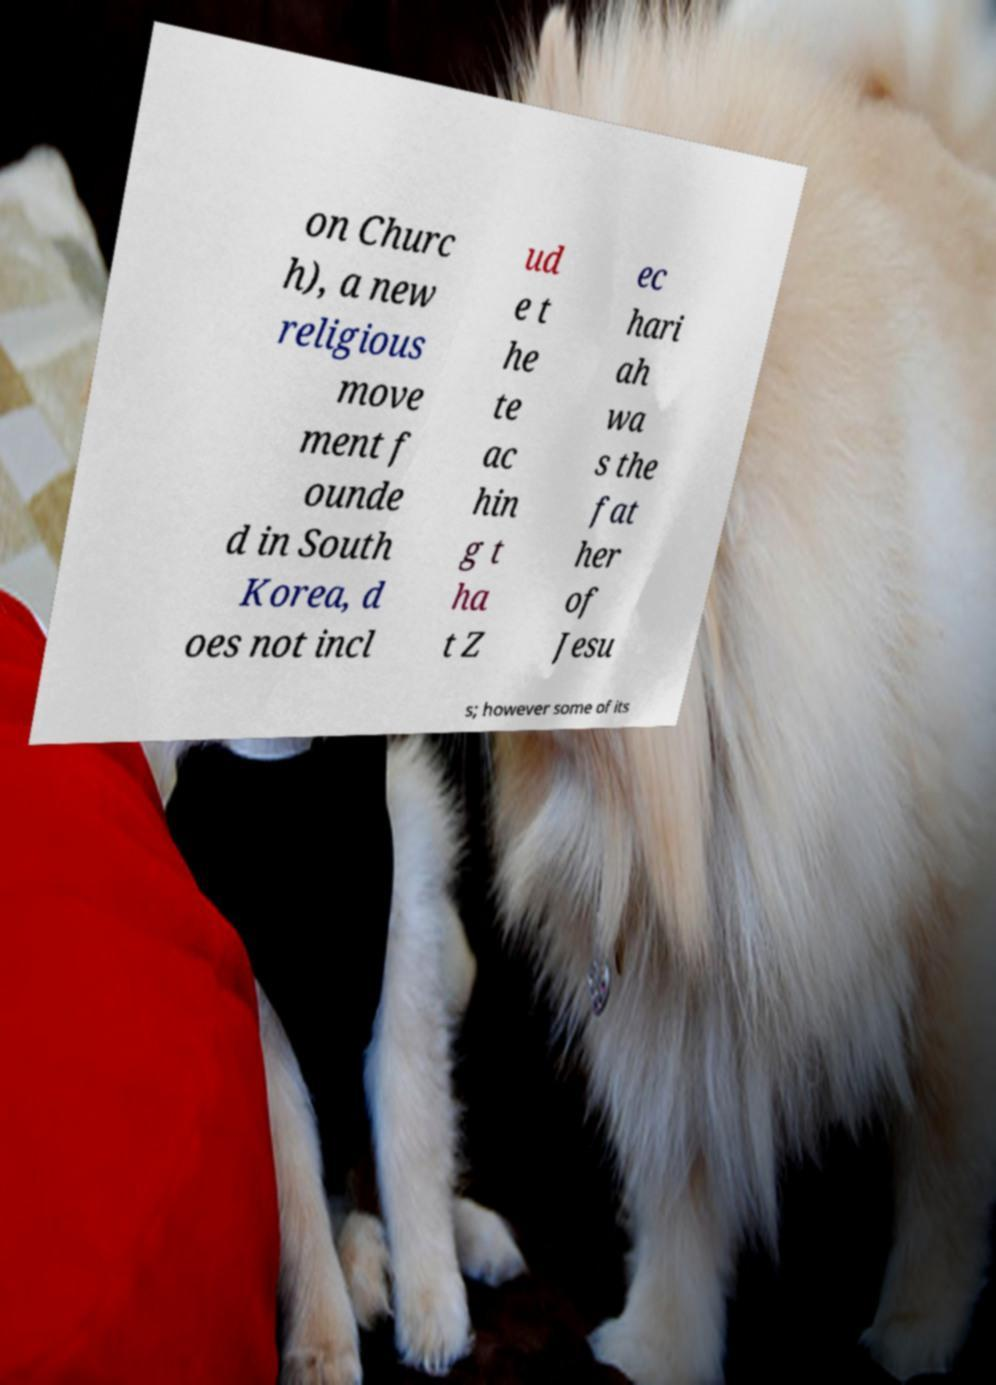Can you accurately transcribe the text from the provided image for me? on Churc h), a new religious move ment f ounde d in South Korea, d oes not incl ud e t he te ac hin g t ha t Z ec hari ah wa s the fat her of Jesu s; however some of its 